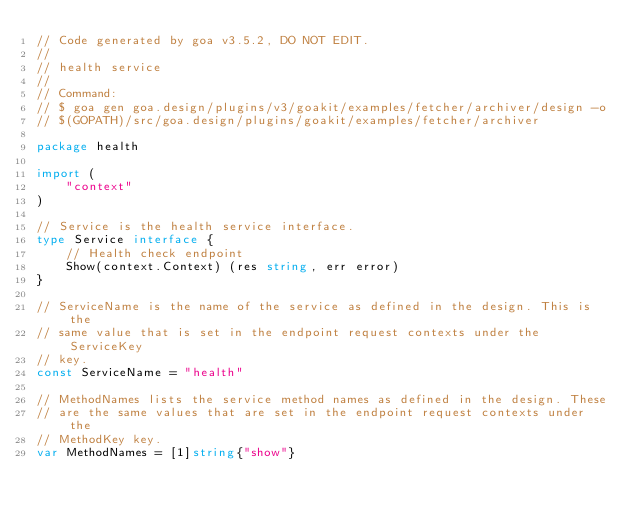<code> <loc_0><loc_0><loc_500><loc_500><_Go_>// Code generated by goa v3.5.2, DO NOT EDIT.
//
// health service
//
// Command:
// $ goa gen goa.design/plugins/v3/goakit/examples/fetcher/archiver/design -o
// $(GOPATH)/src/goa.design/plugins/goakit/examples/fetcher/archiver

package health

import (
	"context"
)

// Service is the health service interface.
type Service interface {
	// Health check endpoint
	Show(context.Context) (res string, err error)
}

// ServiceName is the name of the service as defined in the design. This is the
// same value that is set in the endpoint request contexts under the ServiceKey
// key.
const ServiceName = "health"

// MethodNames lists the service method names as defined in the design. These
// are the same values that are set in the endpoint request contexts under the
// MethodKey key.
var MethodNames = [1]string{"show"}
</code> 